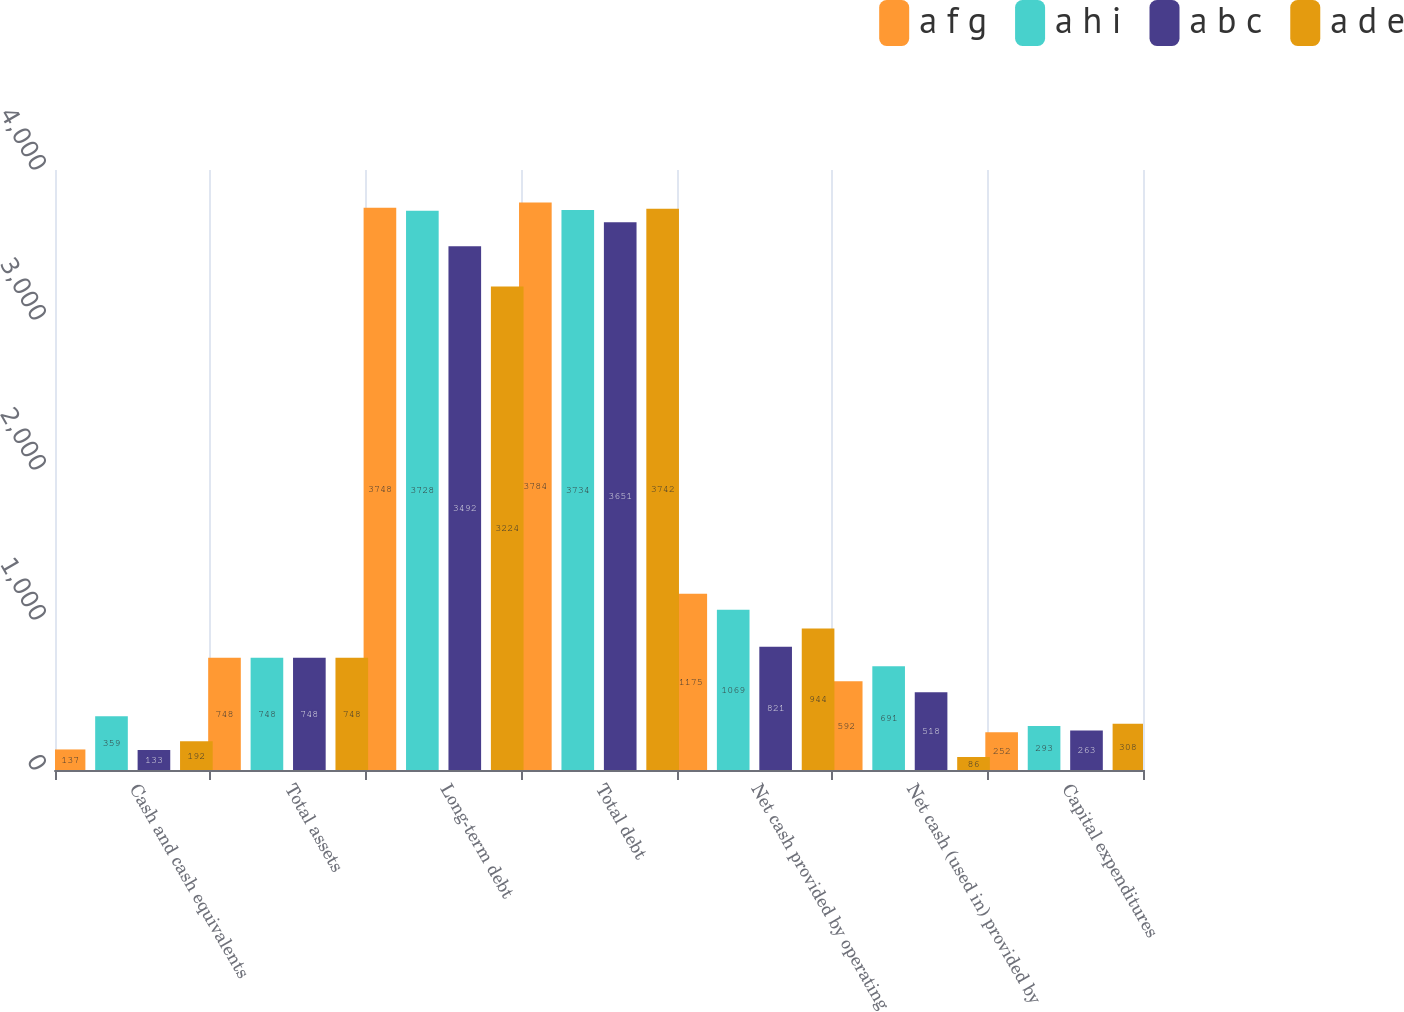Convert chart to OTSL. <chart><loc_0><loc_0><loc_500><loc_500><stacked_bar_chart><ecel><fcel>Cash and cash equivalents<fcel>Total assets<fcel>Long-term debt<fcel>Total debt<fcel>Net cash provided by operating<fcel>Net cash (used in) provided by<fcel>Capital expenditures<nl><fcel>a f g<fcel>137<fcel>748<fcel>3748<fcel>3784<fcel>1175<fcel>592<fcel>252<nl><fcel>a h i<fcel>359<fcel>748<fcel>3728<fcel>3734<fcel>1069<fcel>691<fcel>293<nl><fcel>a b c<fcel>133<fcel>748<fcel>3492<fcel>3651<fcel>821<fcel>518<fcel>263<nl><fcel>a d e<fcel>192<fcel>748<fcel>3224<fcel>3742<fcel>944<fcel>86<fcel>308<nl></chart> 